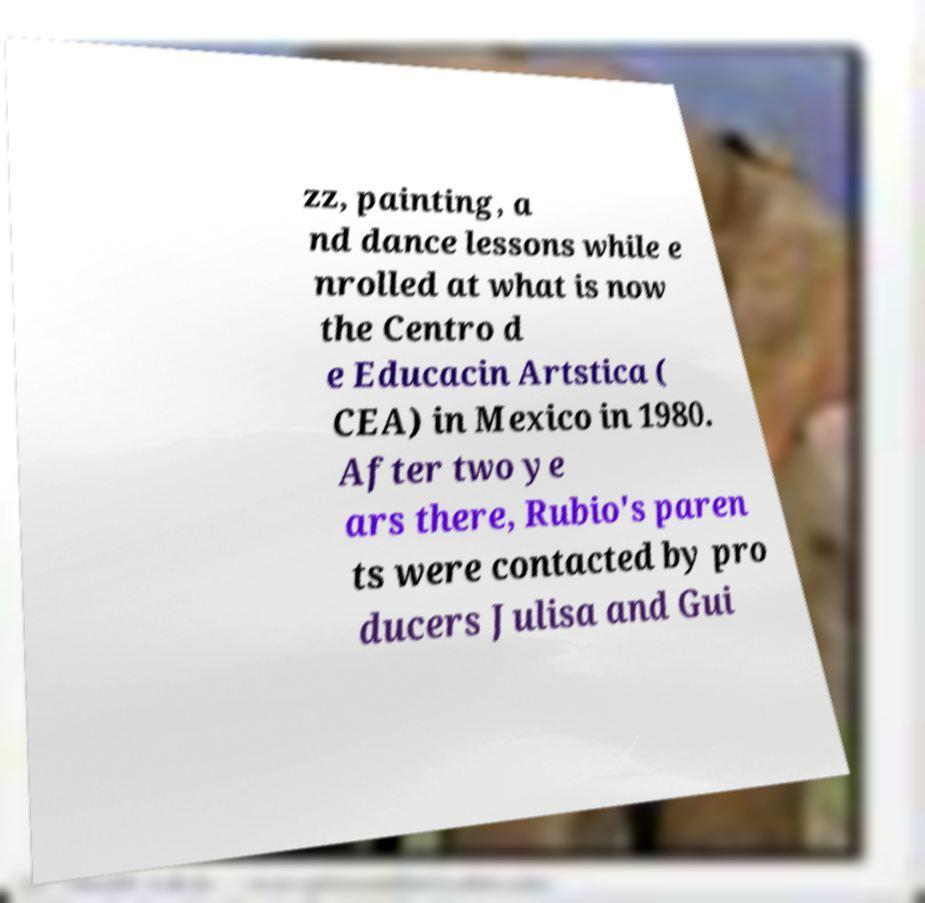There's text embedded in this image that I need extracted. Can you transcribe it verbatim? zz, painting, a nd dance lessons while e nrolled at what is now the Centro d e Educacin Artstica ( CEA) in Mexico in 1980. After two ye ars there, Rubio's paren ts were contacted by pro ducers Julisa and Gui 